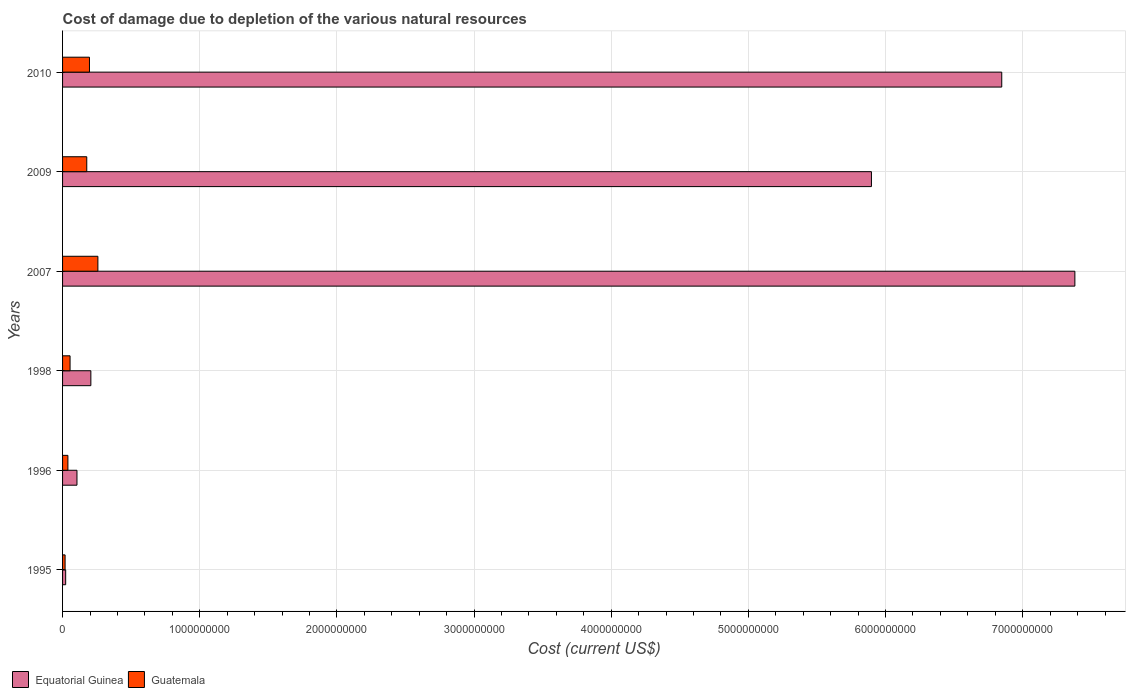How many different coloured bars are there?
Offer a terse response. 2. Are the number of bars on each tick of the Y-axis equal?
Ensure brevity in your answer.  Yes. How many bars are there on the 4th tick from the top?
Ensure brevity in your answer.  2. What is the label of the 4th group of bars from the top?
Offer a terse response. 1998. What is the cost of damage caused due to the depletion of various natural resources in Equatorial Guinea in 1995?
Give a very brief answer. 2.27e+07. Across all years, what is the maximum cost of damage caused due to the depletion of various natural resources in Guatemala?
Make the answer very short. 2.58e+08. Across all years, what is the minimum cost of damage caused due to the depletion of various natural resources in Equatorial Guinea?
Provide a succinct answer. 2.27e+07. In which year was the cost of damage caused due to the depletion of various natural resources in Guatemala minimum?
Offer a terse response. 1995. What is the total cost of damage caused due to the depletion of various natural resources in Guatemala in the graph?
Give a very brief answer. 7.42e+08. What is the difference between the cost of damage caused due to the depletion of various natural resources in Guatemala in 1998 and that in 2009?
Offer a terse response. -1.22e+08. What is the difference between the cost of damage caused due to the depletion of various natural resources in Guatemala in 2010 and the cost of damage caused due to the depletion of various natural resources in Equatorial Guinea in 1995?
Provide a short and direct response. 1.73e+08. What is the average cost of damage caused due to the depletion of various natural resources in Equatorial Guinea per year?
Offer a very short reply. 3.41e+09. In the year 2007, what is the difference between the cost of damage caused due to the depletion of various natural resources in Guatemala and cost of damage caused due to the depletion of various natural resources in Equatorial Guinea?
Your answer should be compact. -7.12e+09. What is the ratio of the cost of damage caused due to the depletion of various natural resources in Guatemala in 1995 to that in 2009?
Make the answer very short. 0.1. What is the difference between the highest and the second highest cost of damage caused due to the depletion of various natural resources in Guatemala?
Your answer should be compact. 6.14e+07. What is the difference between the highest and the lowest cost of damage caused due to the depletion of various natural resources in Guatemala?
Make the answer very short. 2.39e+08. In how many years, is the cost of damage caused due to the depletion of various natural resources in Guatemala greater than the average cost of damage caused due to the depletion of various natural resources in Guatemala taken over all years?
Offer a very short reply. 3. What does the 1st bar from the top in 2010 represents?
Provide a short and direct response. Guatemala. What does the 2nd bar from the bottom in 1995 represents?
Provide a succinct answer. Guatemala. How many bars are there?
Ensure brevity in your answer.  12. Are all the bars in the graph horizontal?
Keep it short and to the point. Yes. How many years are there in the graph?
Offer a very short reply. 6. Does the graph contain grids?
Your answer should be very brief. Yes. How many legend labels are there?
Your answer should be compact. 2. What is the title of the graph?
Your answer should be very brief. Cost of damage due to depletion of the various natural resources. Does "Croatia" appear as one of the legend labels in the graph?
Provide a short and direct response. No. What is the label or title of the X-axis?
Your answer should be very brief. Cost (current US$). What is the label or title of the Y-axis?
Offer a terse response. Years. What is the Cost (current US$) in Equatorial Guinea in 1995?
Provide a short and direct response. 2.27e+07. What is the Cost (current US$) in Guatemala in 1995?
Your response must be concise. 1.85e+07. What is the Cost (current US$) in Equatorial Guinea in 1996?
Give a very brief answer. 1.05e+08. What is the Cost (current US$) of Guatemala in 1996?
Offer a very short reply. 3.89e+07. What is the Cost (current US$) in Equatorial Guinea in 1998?
Your answer should be compact. 2.06e+08. What is the Cost (current US$) of Guatemala in 1998?
Your answer should be compact. 5.47e+07. What is the Cost (current US$) in Equatorial Guinea in 2007?
Provide a short and direct response. 7.38e+09. What is the Cost (current US$) of Guatemala in 2007?
Provide a succinct answer. 2.58e+08. What is the Cost (current US$) in Equatorial Guinea in 2009?
Ensure brevity in your answer.  5.90e+09. What is the Cost (current US$) in Guatemala in 2009?
Make the answer very short. 1.76e+08. What is the Cost (current US$) in Equatorial Guinea in 2010?
Give a very brief answer. 6.85e+09. What is the Cost (current US$) in Guatemala in 2010?
Your answer should be compact. 1.96e+08. Across all years, what is the maximum Cost (current US$) of Equatorial Guinea?
Ensure brevity in your answer.  7.38e+09. Across all years, what is the maximum Cost (current US$) of Guatemala?
Provide a short and direct response. 2.58e+08. Across all years, what is the minimum Cost (current US$) in Equatorial Guinea?
Provide a short and direct response. 2.27e+07. Across all years, what is the minimum Cost (current US$) of Guatemala?
Your answer should be very brief. 1.85e+07. What is the total Cost (current US$) in Equatorial Guinea in the graph?
Offer a terse response. 2.05e+1. What is the total Cost (current US$) in Guatemala in the graph?
Offer a terse response. 7.42e+08. What is the difference between the Cost (current US$) of Equatorial Guinea in 1995 and that in 1996?
Your answer should be very brief. -8.23e+07. What is the difference between the Cost (current US$) of Guatemala in 1995 and that in 1996?
Your answer should be very brief. -2.04e+07. What is the difference between the Cost (current US$) in Equatorial Guinea in 1995 and that in 1998?
Provide a succinct answer. -1.84e+08. What is the difference between the Cost (current US$) of Guatemala in 1995 and that in 1998?
Provide a short and direct response. -3.62e+07. What is the difference between the Cost (current US$) in Equatorial Guinea in 1995 and that in 2007?
Give a very brief answer. -7.36e+09. What is the difference between the Cost (current US$) of Guatemala in 1995 and that in 2007?
Offer a very short reply. -2.39e+08. What is the difference between the Cost (current US$) in Equatorial Guinea in 1995 and that in 2009?
Offer a terse response. -5.87e+09. What is the difference between the Cost (current US$) of Guatemala in 1995 and that in 2009?
Ensure brevity in your answer.  -1.58e+08. What is the difference between the Cost (current US$) of Equatorial Guinea in 1995 and that in 2010?
Ensure brevity in your answer.  -6.82e+09. What is the difference between the Cost (current US$) in Guatemala in 1995 and that in 2010?
Your response must be concise. -1.78e+08. What is the difference between the Cost (current US$) of Equatorial Guinea in 1996 and that in 1998?
Provide a succinct answer. -1.01e+08. What is the difference between the Cost (current US$) of Guatemala in 1996 and that in 1998?
Your response must be concise. -1.58e+07. What is the difference between the Cost (current US$) of Equatorial Guinea in 1996 and that in 2007?
Make the answer very short. -7.28e+09. What is the difference between the Cost (current US$) of Guatemala in 1996 and that in 2007?
Your response must be concise. -2.19e+08. What is the difference between the Cost (current US$) of Equatorial Guinea in 1996 and that in 2009?
Your response must be concise. -5.79e+09. What is the difference between the Cost (current US$) in Guatemala in 1996 and that in 2009?
Give a very brief answer. -1.38e+08. What is the difference between the Cost (current US$) of Equatorial Guinea in 1996 and that in 2010?
Your answer should be compact. -6.74e+09. What is the difference between the Cost (current US$) in Guatemala in 1996 and that in 2010?
Make the answer very short. -1.57e+08. What is the difference between the Cost (current US$) in Equatorial Guinea in 1998 and that in 2007?
Keep it short and to the point. -7.17e+09. What is the difference between the Cost (current US$) of Guatemala in 1998 and that in 2007?
Your answer should be very brief. -2.03e+08. What is the difference between the Cost (current US$) in Equatorial Guinea in 1998 and that in 2009?
Provide a succinct answer. -5.69e+09. What is the difference between the Cost (current US$) of Guatemala in 1998 and that in 2009?
Make the answer very short. -1.22e+08. What is the difference between the Cost (current US$) in Equatorial Guinea in 1998 and that in 2010?
Your response must be concise. -6.64e+09. What is the difference between the Cost (current US$) in Guatemala in 1998 and that in 2010?
Provide a succinct answer. -1.41e+08. What is the difference between the Cost (current US$) in Equatorial Guinea in 2007 and that in 2009?
Make the answer very short. 1.48e+09. What is the difference between the Cost (current US$) in Guatemala in 2007 and that in 2009?
Offer a very short reply. 8.10e+07. What is the difference between the Cost (current US$) in Equatorial Guinea in 2007 and that in 2010?
Make the answer very short. 5.33e+08. What is the difference between the Cost (current US$) in Guatemala in 2007 and that in 2010?
Make the answer very short. 6.14e+07. What is the difference between the Cost (current US$) in Equatorial Guinea in 2009 and that in 2010?
Your answer should be very brief. -9.50e+08. What is the difference between the Cost (current US$) of Guatemala in 2009 and that in 2010?
Keep it short and to the point. -1.96e+07. What is the difference between the Cost (current US$) in Equatorial Guinea in 1995 and the Cost (current US$) in Guatemala in 1996?
Offer a very short reply. -1.62e+07. What is the difference between the Cost (current US$) in Equatorial Guinea in 1995 and the Cost (current US$) in Guatemala in 1998?
Offer a very short reply. -3.20e+07. What is the difference between the Cost (current US$) of Equatorial Guinea in 1995 and the Cost (current US$) of Guatemala in 2007?
Offer a terse response. -2.35e+08. What is the difference between the Cost (current US$) in Equatorial Guinea in 1995 and the Cost (current US$) in Guatemala in 2009?
Provide a short and direct response. -1.54e+08. What is the difference between the Cost (current US$) in Equatorial Guinea in 1995 and the Cost (current US$) in Guatemala in 2010?
Your response must be concise. -1.73e+08. What is the difference between the Cost (current US$) of Equatorial Guinea in 1996 and the Cost (current US$) of Guatemala in 1998?
Ensure brevity in your answer.  5.04e+07. What is the difference between the Cost (current US$) of Equatorial Guinea in 1996 and the Cost (current US$) of Guatemala in 2007?
Your answer should be compact. -1.52e+08. What is the difference between the Cost (current US$) in Equatorial Guinea in 1996 and the Cost (current US$) in Guatemala in 2009?
Give a very brief answer. -7.14e+07. What is the difference between the Cost (current US$) in Equatorial Guinea in 1996 and the Cost (current US$) in Guatemala in 2010?
Your answer should be compact. -9.11e+07. What is the difference between the Cost (current US$) in Equatorial Guinea in 1998 and the Cost (current US$) in Guatemala in 2007?
Offer a terse response. -5.12e+07. What is the difference between the Cost (current US$) in Equatorial Guinea in 1998 and the Cost (current US$) in Guatemala in 2009?
Your answer should be very brief. 2.98e+07. What is the difference between the Cost (current US$) in Equatorial Guinea in 1998 and the Cost (current US$) in Guatemala in 2010?
Give a very brief answer. 1.02e+07. What is the difference between the Cost (current US$) of Equatorial Guinea in 2007 and the Cost (current US$) of Guatemala in 2009?
Your response must be concise. 7.20e+09. What is the difference between the Cost (current US$) in Equatorial Guinea in 2007 and the Cost (current US$) in Guatemala in 2010?
Ensure brevity in your answer.  7.18e+09. What is the difference between the Cost (current US$) of Equatorial Guinea in 2009 and the Cost (current US$) of Guatemala in 2010?
Ensure brevity in your answer.  5.70e+09. What is the average Cost (current US$) in Equatorial Guinea per year?
Give a very brief answer. 3.41e+09. What is the average Cost (current US$) of Guatemala per year?
Your response must be concise. 1.24e+08. In the year 1995, what is the difference between the Cost (current US$) of Equatorial Guinea and Cost (current US$) of Guatemala?
Your answer should be very brief. 4.22e+06. In the year 1996, what is the difference between the Cost (current US$) in Equatorial Guinea and Cost (current US$) in Guatemala?
Give a very brief answer. 6.61e+07. In the year 1998, what is the difference between the Cost (current US$) of Equatorial Guinea and Cost (current US$) of Guatemala?
Make the answer very short. 1.52e+08. In the year 2007, what is the difference between the Cost (current US$) of Equatorial Guinea and Cost (current US$) of Guatemala?
Your answer should be very brief. 7.12e+09. In the year 2009, what is the difference between the Cost (current US$) of Equatorial Guinea and Cost (current US$) of Guatemala?
Your answer should be very brief. 5.72e+09. In the year 2010, what is the difference between the Cost (current US$) in Equatorial Guinea and Cost (current US$) in Guatemala?
Keep it short and to the point. 6.65e+09. What is the ratio of the Cost (current US$) in Equatorial Guinea in 1995 to that in 1996?
Offer a very short reply. 0.22. What is the ratio of the Cost (current US$) of Guatemala in 1995 to that in 1996?
Your answer should be compact. 0.47. What is the ratio of the Cost (current US$) in Equatorial Guinea in 1995 to that in 1998?
Ensure brevity in your answer.  0.11. What is the ratio of the Cost (current US$) of Guatemala in 1995 to that in 1998?
Offer a terse response. 0.34. What is the ratio of the Cost (current US$) in Equatorial Guinea in 1995 to that in 2007?
Give a very brief answer. 0. What is the ratio of the Cost (current US$) of Guatemala in 1995 to that in 2007?
Keep it short and to the point. 0.07. What is the ratio of the Cost (current US$) in Equatorial Guinea in 1995 to that in 2009?
Keep it short and to the point. 0. What is the ratio of the Cost (current US$) in Guatemala in 1995 to that in 2009?
Give a very brief answer. 0.1. What is the ratio of the Cost (current US$) in Equatorial Guinea in 1995 to that in 2010?
Provide a succinct answer. 0. What is the ratio of the Cost (current US$) of Guatemala in 1995 to that in 2010?
Your answer should be compact. 0.09. What is the ratio of the Cost (current US$) in Equatorial Guinea in 1996 to that in 1998?
Your answer should be compact. 0.51. What is the ratio of the Cost (current US$) in Guatemala in 1996 to that in 1998?
Make the answer very short. 0.71. What is the ratio of the Cost (current US$) in Equatorial Guinea in 1996 to that in 2007?
Make the answer very short. 0.01. What is the ratio of the Cost (current US$) in Guatemala in 1996 to that in 2007?
Provide a short and direct response. 0.15. What is the ratio of the Cost (current US$) of Equatorial Guinea in 1996 to that in 2009?
Offer a very short reply. 0.02. What is the ratio of the Cost (current US$) in Guatemala in 1996 to that in 2009?
Offer a very short reply. 0.22. What is the ratio of the Cost (current US$) in Equatorial Guinea in 1996 to that in 2010?
Your response must be concise. 0.02. What is the ratio of the Cost (current US$) of Guatemala in 1996 to that in 2010?
Make the answer very short. 0.2. What is the ratio of the Cost (current US$) in Equatorial Guinea in 1998 to that in 2007?
Your answer should be very brief. 0.03. What is the ratio of the Cost (current US$) of Guatemala in 1998 to that in 2007?
Provide a short and direct response. 0.21. What is the ratio of the Cost (current US$) in Equatorial Guinea in 1998 to that in 2009?
Give a very brief answer. 0.04. What is the ratio of the Cost (current US$) in Guatemala in 1998 to that in 2009?
Keep it short and to the point. 0.31. What is the ratio of the Cost (current US$) in Equatorial Guinea in 1998 to that in 2010?
Keep it short and to the point. 0.03. What is the ratio of the Cost (current US$) of Guatemala in 1998 to that in 2010?
Give a very brief answer. 0.28. What is the ratio of the Cost (current US$) of Equatorial Guinea in 2007 to that in 2009?
Keep it short and to the point. 1.25. What is the ratio of the Cost (current US$) of Guatemala in 2007 to that in 2009?
Offer a terse response. 1.46. What is the ratio of the Cost (current US$) in Equatorial Guinea in 2007 to that in 2010?
Your response must be concise. 1.08. What is the ratio of the Cost (current US$) in Guatemala in 2007 to that in 2010?
Ensure brevity in your answer.  1.31. What is the ratio of the Cost (current US$) in Equatorial Guinea in 2009 to that in 2010?
Make the answer very short. 0.86. What is the ratio of the Cost (current US$) in Guatemala in 2009 to that in 2010?
Keep it short and to the point. 0.9. What is the difference between the highest and the second highest Cost (current US$) of Equatorial Guinea?
Make the answer very short. 5.33e+08. What is the difference between the highest and the second highest Cost (current US$) in Guatemala?
Offer a very short reply. 6.14e+07. What is the difference between the highest and the lowest Cost (current US$) of Equatorial Guinea?
Ensure brevity in your answer.  7.36e+09. What is the difference between the highest and the lowest Cost (current US$) of Guatemala?
Ensure brevity in your answer.  2.39e+08. 